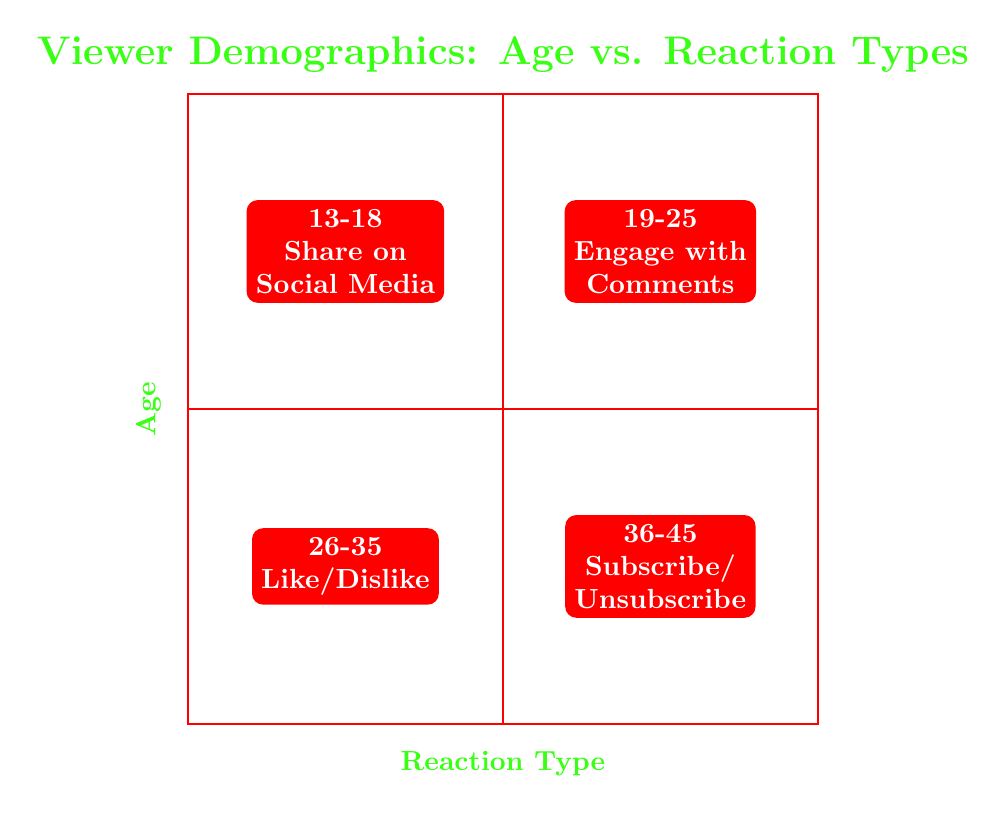What is the reaction type for the age group 13-18? Referring to the top left quadrant of the diagram, the label indicates that for the age group 13-18, the reaction type is "Share on Social Media."
Answer: Share on Social Media How many total age groups are represented in the diagram? The diagram has four quadrants, each representing a different age group (13-18, 19-25, 26-35, 36-45). Therefore, there are a total of four age groups.
Answer: 4 Which age group engages with comments? Looking at the top right quadrant of the diagram, it states that the age group 19-25 is associated with the reaction type "Engage with Comments."
Answer: 19-25 What is the reaction type associated with the age group 26-35? In the bottom left quadrant of the diagram, it specifies that the reaction type for the age group 26-35 is "Like/Dislike."
Answer: Like/Dislike Which quadrants represent age groups that take subscriber actions? The bottom right quadrant specifies that the age group 36-45 corresponds to the reaction type "Subscribe/Unsubscribe." Thus, this quadrant represents the subscriber action.
Answer: 36-45 What can be inferred about younger viewers' reactions compared to older viewers? Younger viewers (13-18 and 19-25) tend to engage more through sharing and commenting, whereas older viewers (26-35 and 36-45) focus on likes/dislikes and subscription actions. This indicates a trend where younger viewers prefer immediate social interaction while older viewers are more inclined towards commitment.
Answer: Younger viewers share and comment, older viewers like/dislike and subscribe 